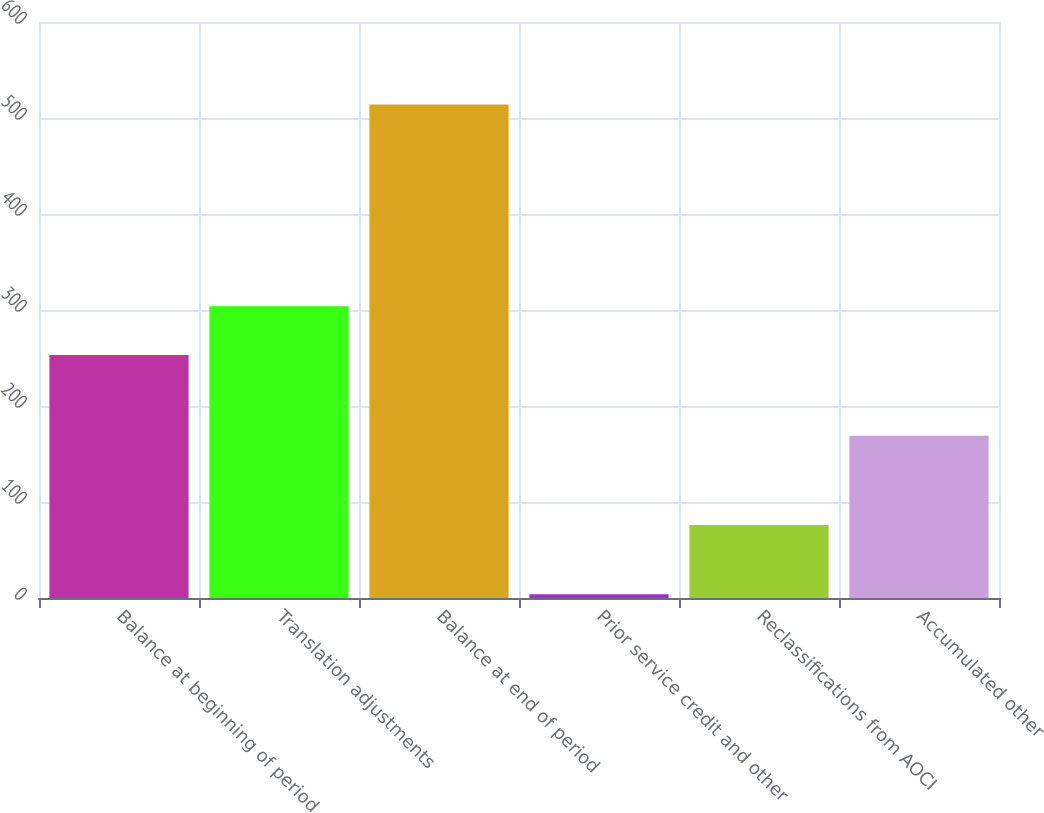Convert chart. <chart><loc_0><loc_0><loc_500><loc_500><bar_chart><fcel>Balance at beginning of period<fcel>Translation adjustments<fcel>Balance at end of period<fcel>Prior service credit and other<fcel>Reclassifications from AOCI<fcel>Accumulated other<nl><fcel>253<fcel>304<fcel>514<fcel>4<fcel>76<fcel>169<nl></chart> 